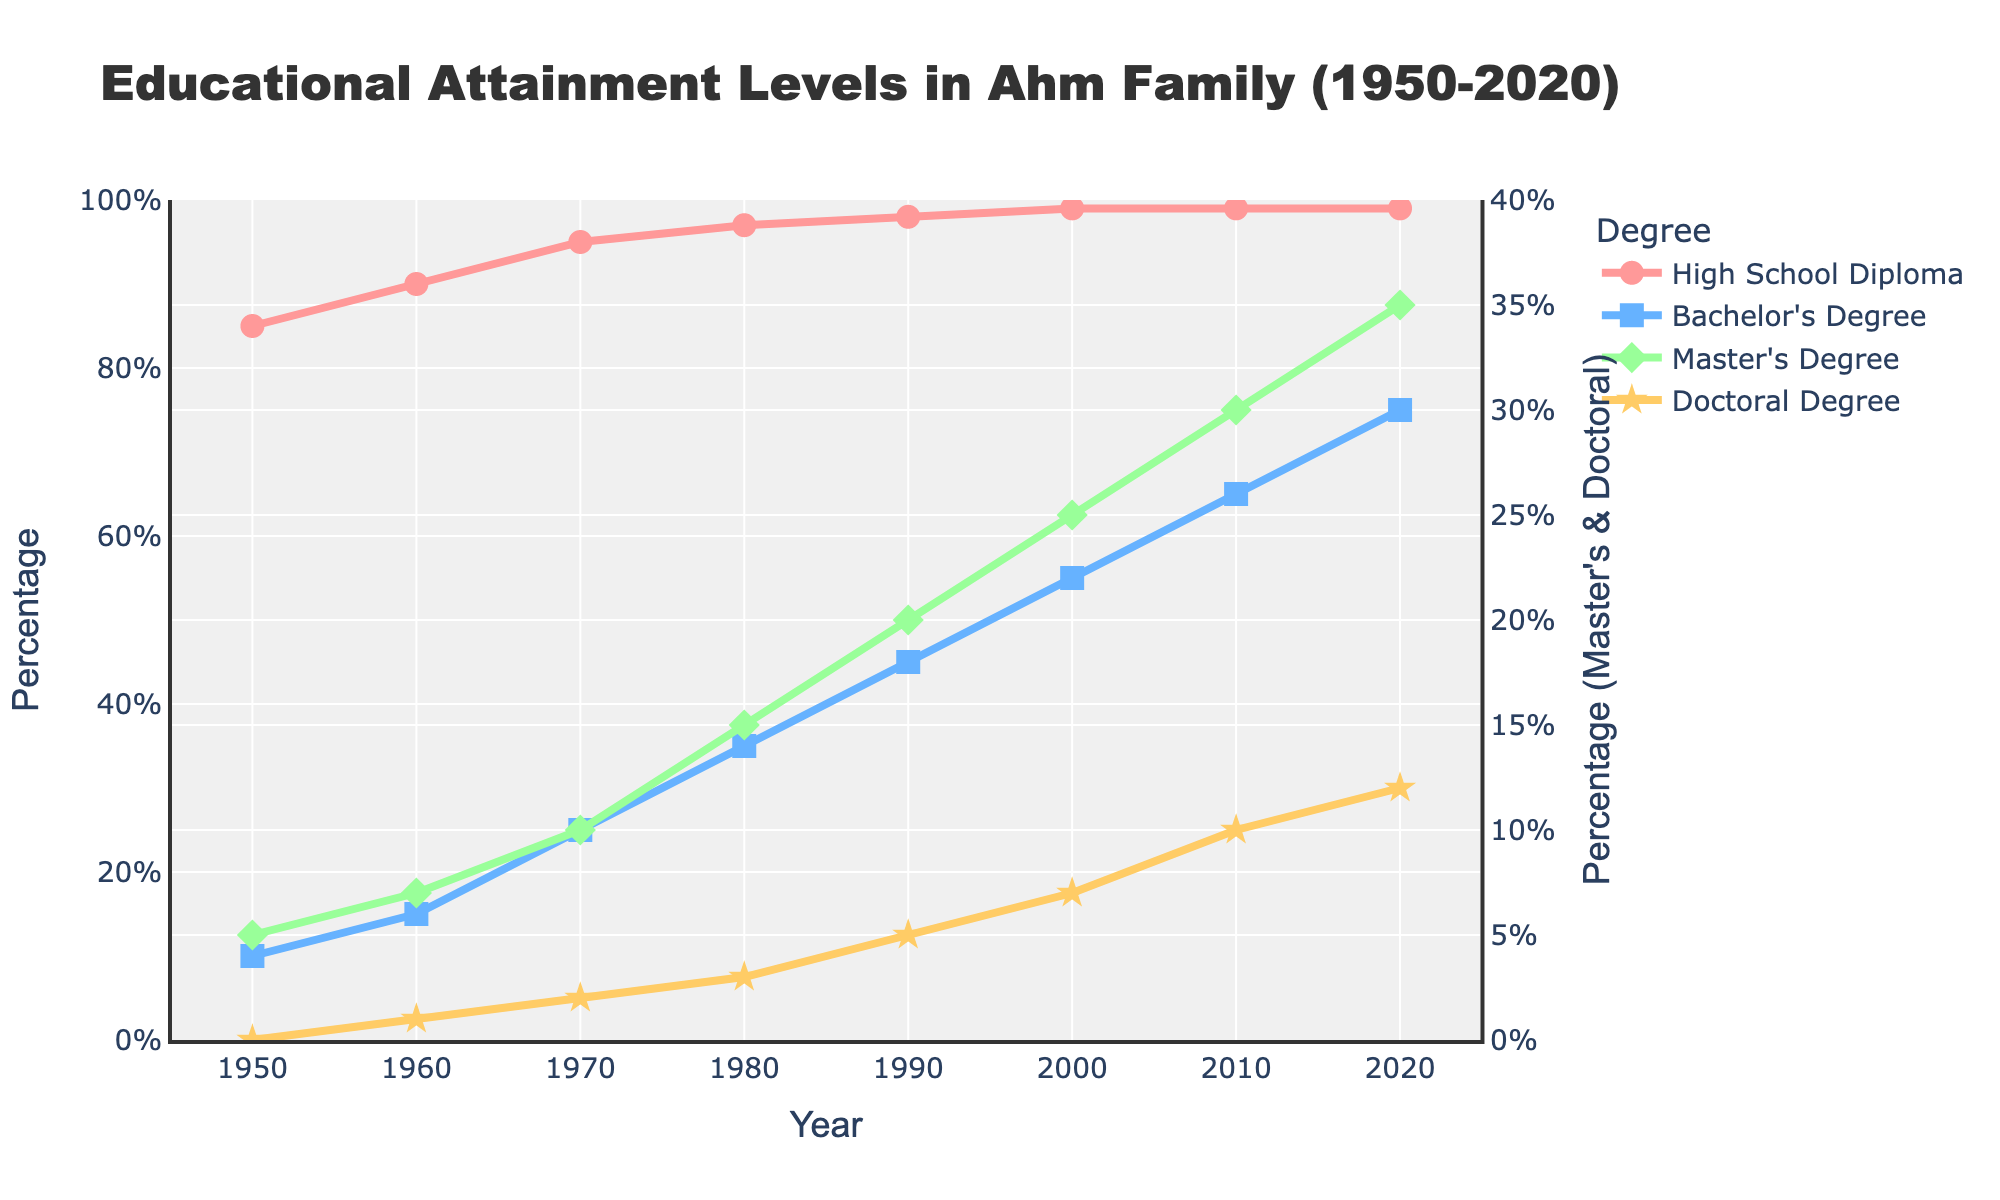What's the percentage increase in family members obtaining a Bachelor's Degree from 1950 to 2020? To calculate the percentage increase, subtract the percentage in 1950 from the percentage in 2020, and then divide the result by the percentage in 1950 and multiply by 100. This gives: ((75 - 10) / 10) * 100.
Answer: 650% What is the visual pattern of the lines representing 'High School Diploma' and 'Master's Degree'? The line for 'High School Diploma' is red and shows a steady, small increase, while the line for 'Master's Degree' is green and also shows a consistent increase but at a different rate and with more spikes.
Answer: A steady red line for High School Diploma and a steady green line with spikes for Master's Degree Between 1960 and 1980, which degree saw the largest percentage increase? To determine this, calculate the percentage increase for each degree between 1960 and 1980: High School Diploma (97 - 90) = 7%, Bachelor’s Degree (35 - 15) = 20%, Master’s Degree (15 - 7) = 8%, Doctoral Degree (3 - 1) = 2%. The Bachelor's Degree had the largest increase of 20%.
Answer: Bachelor's Degree Comparing 1990 to 2000, which degree experienced the least change in percentage? For each degree, calculate the change from 1990 to 2000: High School Diploma (99 - 98) = 1%, Bachelor’s Degree (55 - 45) = 10%, Master’s Degree (25 - 20) = 5%, Doctoral Degree (7 - 5) = 2%. The High School Diploma experienced the least change of 1%.
Answer: High School Diploma What is the combined percentage of Ahm family members with a Master's and Doctoral degree in 2010? Sum the percentages of Master's Degree and Doctoral Degree in 2010: 30% + 10% = 40%.
Answer: 40% How many years did it take for the percentage of family members with a Bachelor's Degree to exceed 50%? Examine the figure and find the first year the Bachelor's Degree exceeds 50%, which is 2000. Subtract the starting year (1950) from 2000: 2000 - 1950 = 50 years.
Answer: 50 years Which year saw the highest percentage of family members with a Doctoral Degree, and what was the value? Check the graph for the highest point on the Doctoral Degree line, which is in 2020 with a percentage of 12%.
Answer: 2020, 12% If you look at the trend for 'Master's Degree' from 1950 to 2020, how would you describe the pattern? The pattern indicates a steady increase in the percentage of family members obtaining a Master's Degree over time, with an increase from 5% in 1950 to 35% in 2020.
Answer: Steady increase What is the difference in percentage points for family members achieving a High School Diploma between 1950 and 2020? Subtract the 1950 percentage from the 2020 percentage for High School Diploma: 99% - 85% = 14 percentage points.
Answer: 14 percentage points 